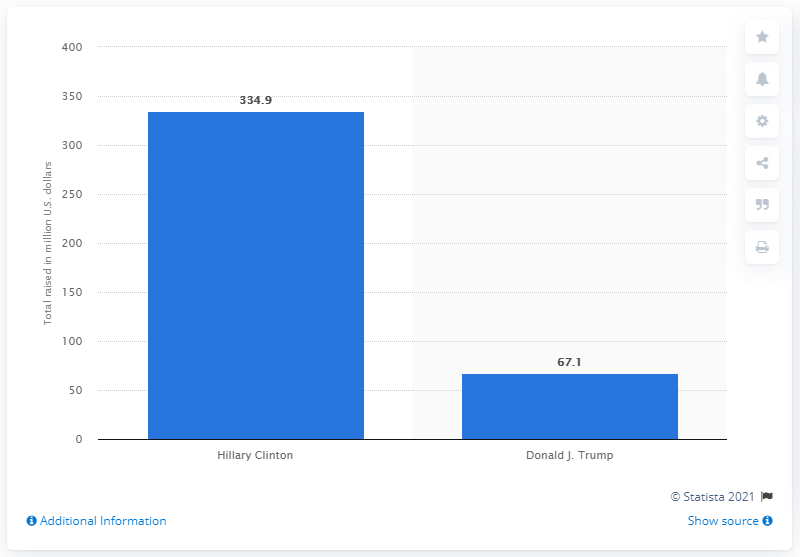Outline some significant characteristics in this image. As of June 22, Hillary Clinton had raised the most amount of money out of all the candidates. As of June 22, 2016, Hillary Clinton had raised a significant amount of money. 